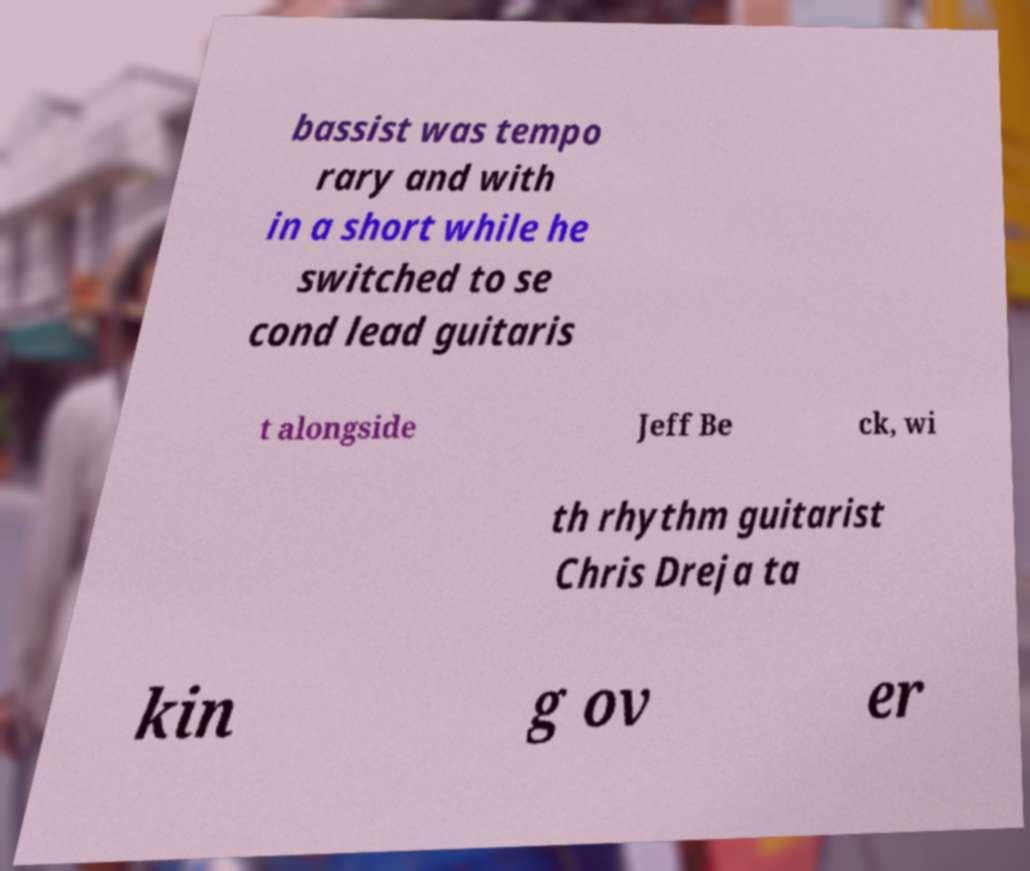For documentation purposes, I need the text within this image transcribed. Could you provide that? bassist was tempo rary and with in a short while he switched to se cond lead guitaris t alongside Jeff Be ck, wi th rhythm guitarist Chris Dreja ta kin g ov er 